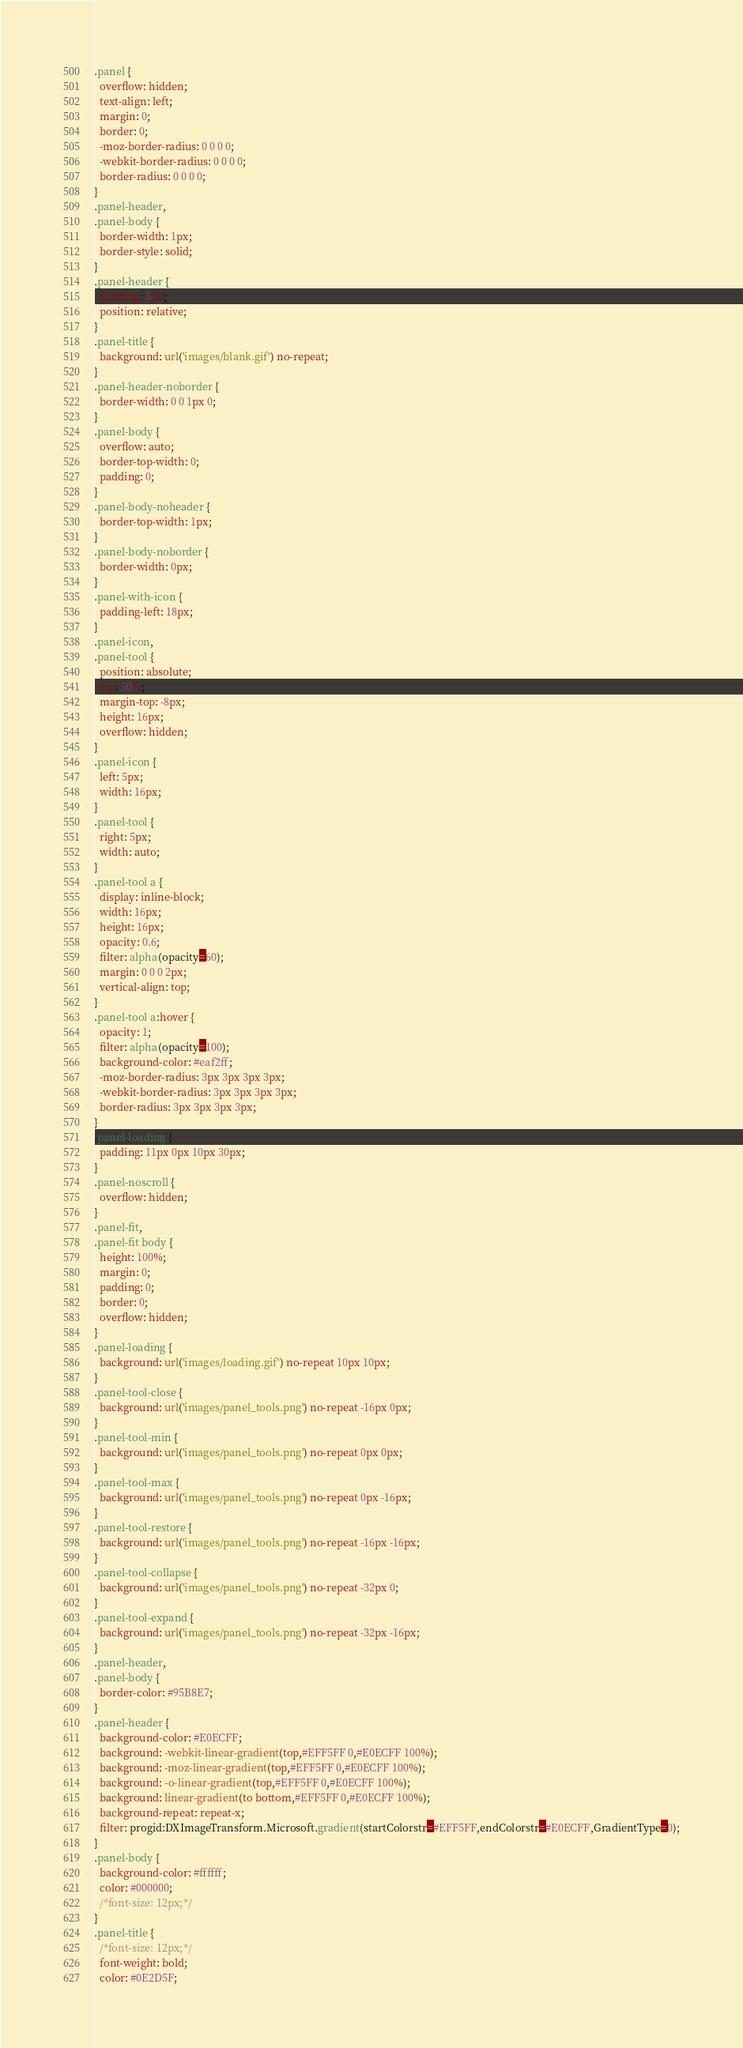<code> <loc_0><loc_0><loc_500><loc_500><_CSS_>.panel {
  overflow: hidden;
  text-align: left;
  margin: 0;
  border: 0;
  -moz-border-radius: 0 0 0 0;
  -webkit-border-radius: 0 0 0 0;
  border-radius: 0 0 0 0;
}
.panel-header,
.panel-body {
  border-width: 1px;
  border-style: solid;
}
.panel-header {
  padding: 5px;
  position: relative;
}
.panel-title {
  background: url('images/blank.gif') no-repeat;
}
.panel-header-noborder {
  border-width: 0 0 1px 0;
}
.panel-body {
  overflow: auto;
  border-top-width: 0;
  padding: 0;
}
.panel-body-noheader {
  border-top-width: 1px;
}
.panel-body-noborder {
  border-width: 0px;
}
.panel-with-icon {
  padding-left: 18px;
}
.panel-icon,
.panel-tool {
  position: absolute;
  top: 50%;
  margin-top: -8px;
  height: 16px;
  overflow: hidden;
}
.panel-icon {
  left: 5px;
  width: 16px;
}
.panel-tool {
  right: 5px;
  width: auto;
}
.panel-tool a {
  display: inline-block;
  width: 16px;
  height: 16px;
  opacity: 0.6;
  filter: alpha(opacity=60);
  margin: 0 0 0 2px;
  vertical-align: top;
}
.panel-tool a:hover {
  opacity: 1;
  filter: alpha(opacity=100);
  background-color: #eaf2ff;
  -moz-border-radius: 3px 3px 3px 3px;
  -webkit-border-radius: 3px 3px 3px 3px;
  border-radius: 3px 3px 3px 3px;
}
.panel-loading {
  padding: 11px 0px 10px 30px;
}
.panel-noscroll {
  overflow: hidden;
}
.panel-fit,
.panel-fit body {
  height: 100%;
  margin: 0;
  padding: 0;
  border: 0;
  overflow: hidden;
}
.panel-loading {
  background: url('images/loading.gif') no-repeat 10px 10px;
}
.panel-tool-close {
  background: url('images/panel_tools.png') no-repeat -16px 0px;
}
.panel-tool-min {
  background: url('images/panel_tools.png') no-repeat 0px 0px;
}
.panel-tool-max {
  background: url('images/panel_tools.png') no-repeat 0px -16px;
}
.panel-tool-restore {
  background: url('images/panel_tools.png') no-repeat -16px -16px;
}
.panel-tool-collapse {
  background: url('images/panel_tools.png') no-repeat -32px 0;
}
.panel-tool-expand {
  background: url('images/panel_tools.png') no-repeat -32px -16px;
}
.panel-header,
.panel-body {
  border-color: #95B8E7;
}
.panel-header {
  background-color: #E0ECFF;
  background: -webkit-linear-gradient(top,#EFF5FF 0,#E0ECFF 100%);
  background: -moz-linear-gradient(top,#EFF5FF 0,#E0ECFF 100%);
  background: -o-linear-gradient(top,#EFF5FF 0,#E0ECFF 100%);
  background: linear-gradient(to bottom,#EFF5FF 0,#E0ECFF 100%);
  background-repeat: repeat-x;
  filter: progid:DXImageTransform.Microsoft.gradient(startColorstr=#EFF5FF,endColorstr=#E0ECFF,GradientType=0);
}
.panel-body {
  background-color: #ffffff;
  color: #000000;
  /*font-size: 12px;*/
}
.panel-title {
  /*font-size: 12px;*/
  font-weight: bold;
  color: #0E2D5F;</code> 